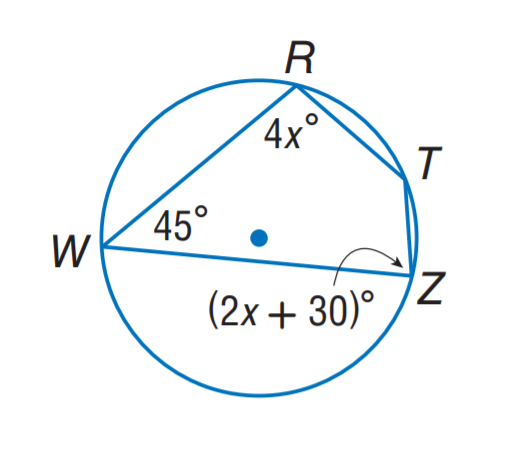Question: Find m \angle T.
Choices:
A. 80
B. 120
C. 135
D. 145
Answer with the letter. Answer: C Question: Find m \angle Z.
Choices:
A. 60
B. 80
C. 120
D. 135
Answer with the letter. Answer: B 